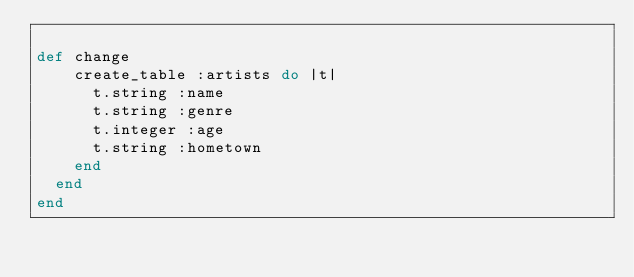Convert code to text. <code><loc_0><loc_0><loc_500><loc_500><_Ruby_>
def change
    create_table :artists do |t|
      t.string :name
      t.string :genre
      t.integer :age
      t.string :hometown
    end
  end
end</code> 